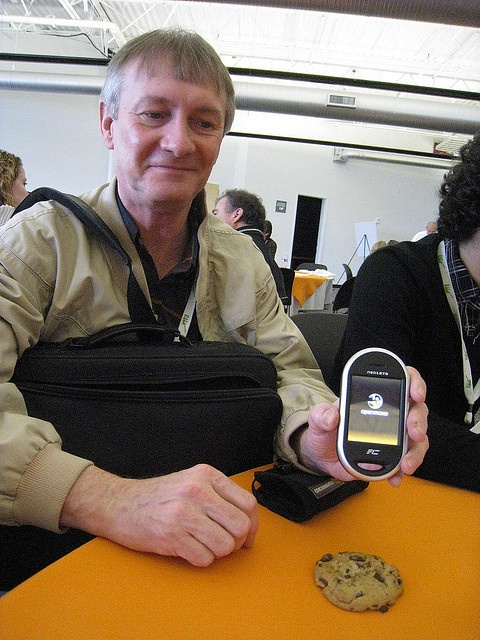Describe the objects in this image and their specific colors. I can see people in darkgray, gray, and black tones, dining table in darkgray, orange, and maroon tones, handbag in darkgray, black, and gray tones, people in darkgray, black, gray, and lightgray tones, and cell phone in darkgray, black, gray, and white tones in this image. 